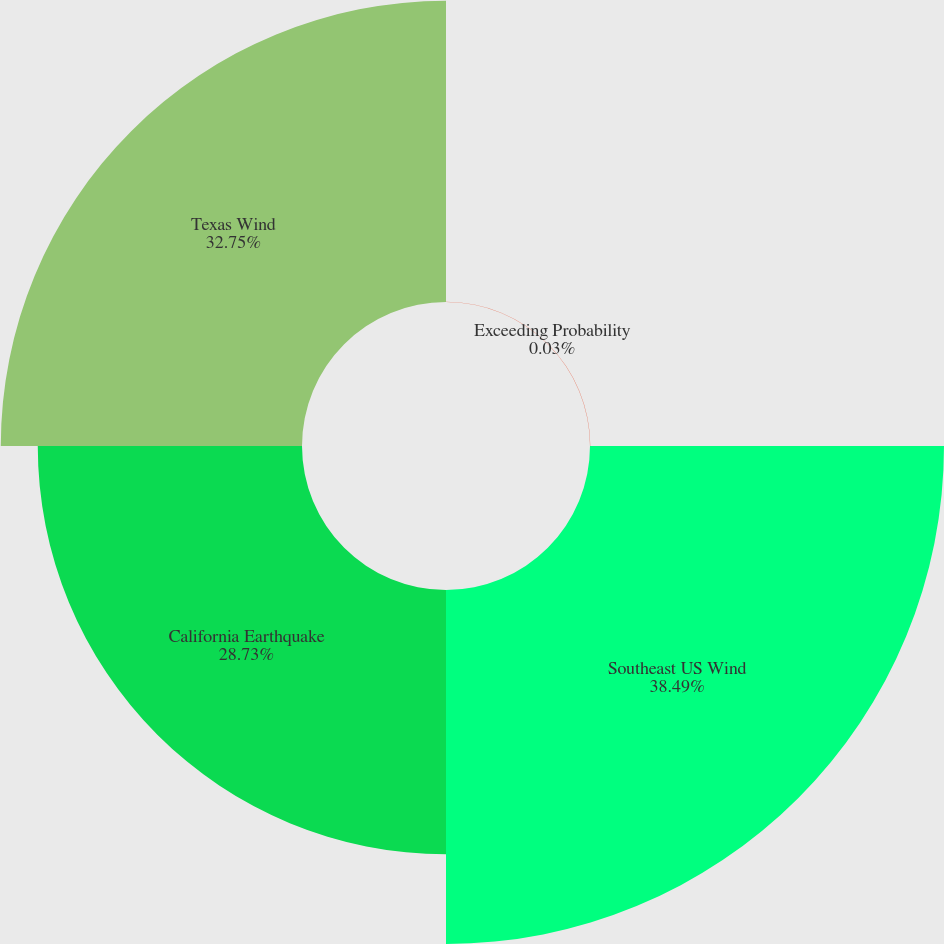Convert chart to OTSL. <chart><loc_0><loc_0><loc_500><loc_500><pie_chart><fcel>Exceeding Probability<fcel>Southeast US Wind<fcel>California Earthquake<fcel>Texas Wind<nl><fcel>0.03%<fcel>38.49%<fcel>28.73%<fcel>32.75%<nl></chart> 